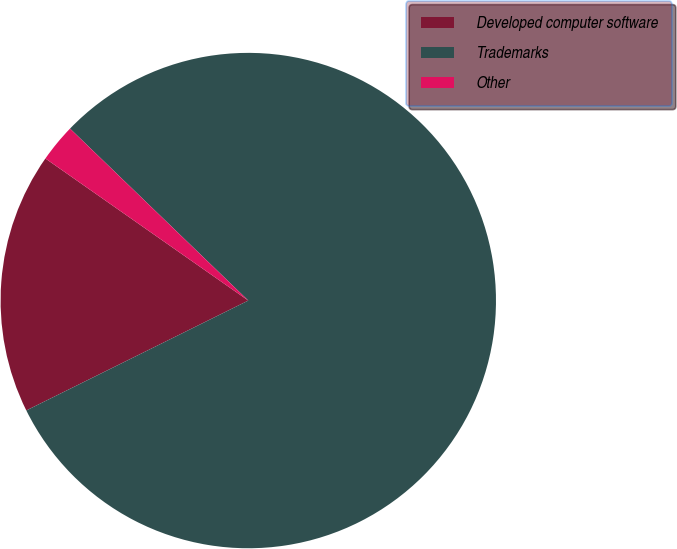Convert chart to OTSL. <chart><loc_0><loc_0><loc_500><loc_500><pie_chart><fcel>Developed computer software<fcel>Trademarks<fcel>Other<nl><fcel>17.04%<fcel>80.47%<fcel>2.49%<nl></chart> 